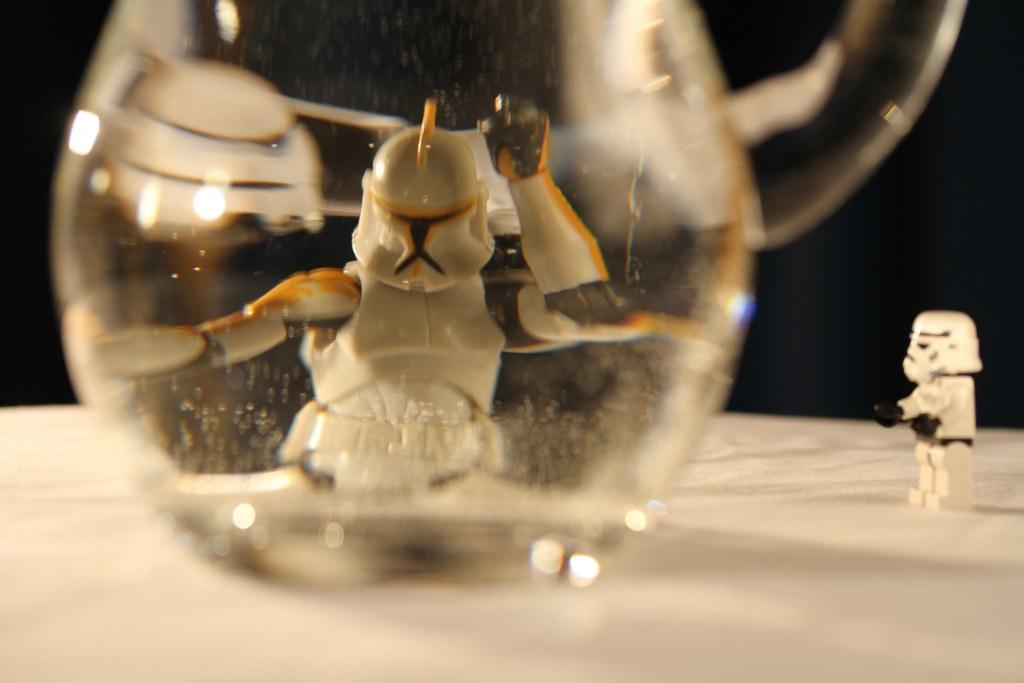What type of object is made of glass in the image? There is a glass object in the image. What other type of object can be seen in the image? There is a toy in the image. On what surface is the glass object placed? The glass object is placed on a white surface. How would you describe the overall lighting or color of the image? The background of the image is dark. How many balloons are floating in the image? There are no balloons present in the image. What type of pets can be seen playing with the toy in the image? There are no pets visible in the image; only the glass object and the toy are present. 